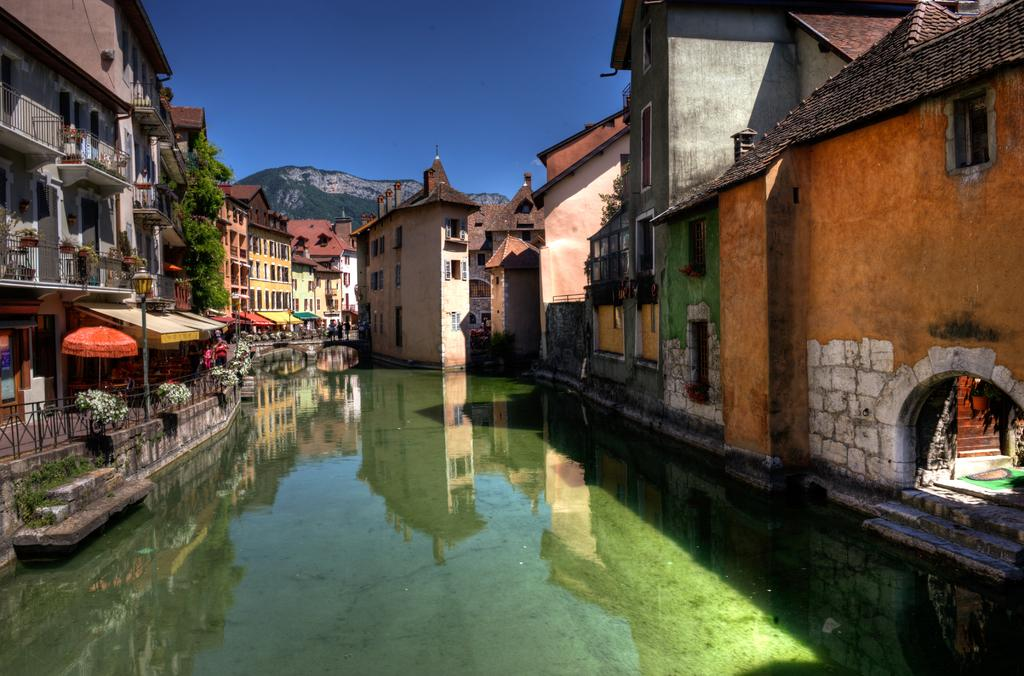What type of structures can be seen in the image? There are buildings, sheds, and a fence in the image. What other objects are present in the image? There are poles, plants, and an umbrella visible in the image. What natural features can be seen in the image? There are hills and water with a reflection in the image. What is visible in the sky? The sky is visible in the image. What type of flowers can be seen growing near the water in the image? There are no flowers visible in the image; it only shows plants, not specifically flowers. What activity is taking place near the water in the image? There is no activity taking place near the water in the image; it only shows a reflection of the surroundings. 